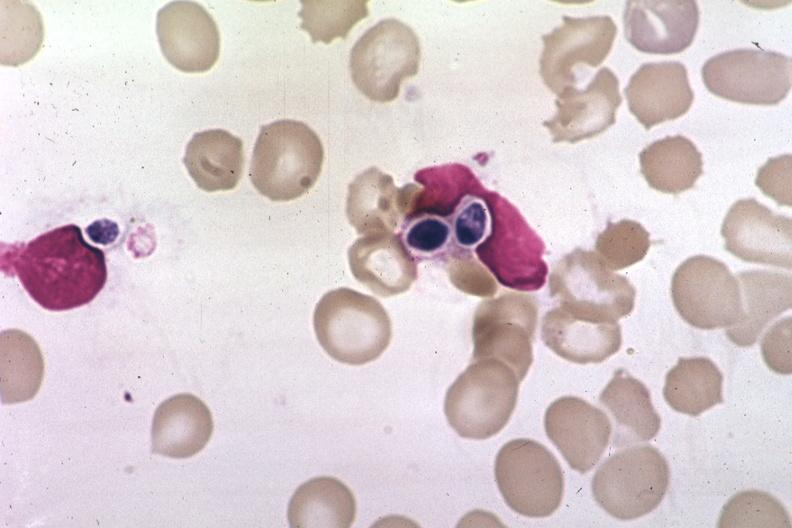s intrauterine contraceptive device present?
Answer the question using a single word or phrase. No 